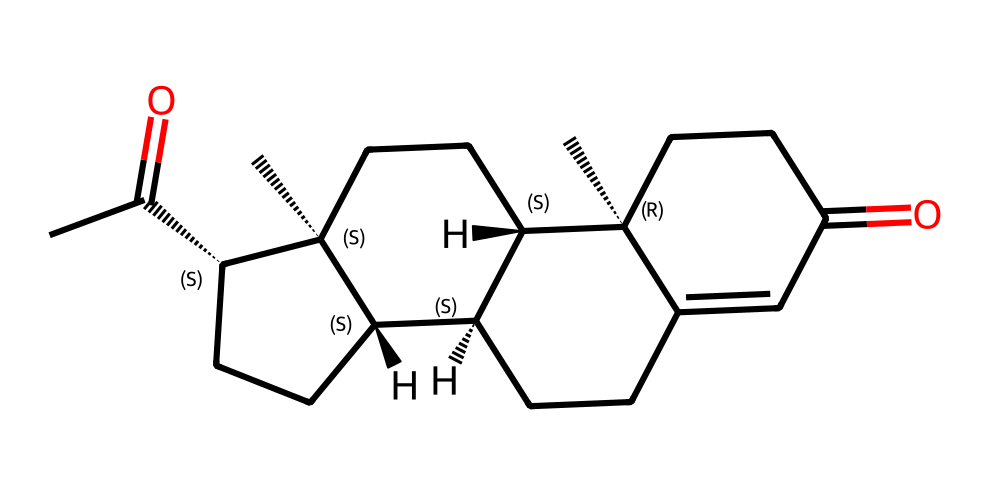What is the molecular formula of this chemical? The SMILES representation can be converted to determine the molecular formula by counting the number of each type of atom present. In this case, the chemical consists of 21 carbon atoms, 30 hydrogen atoms, and 2 oxygen atoms, leading to the formula C21H30O2.
Answer: C21H30O2 How many rings are present in the structure? By analyzing the structure represented in the SMILES, we can identify that there are four rings in the steroid-type molecule represented. This is common for lipids like progesterone.
Answer: 4 What kind of functional groups are present? The SMILES notation indicates the presence of ketones (C=O) and hydroxyl groups (if present); here, we see that the molecule contains two ketone functional groups indicated by the =O notation. There are no hydroxyl groups in the provided structure.
Answer: ketone What is the role of this hormone in pregnancy? Progesterone plays a crucial role in preparing the uterus for implantation and maintaining pregnancy. It helps in regulating various functions in the female reproductive system due to its hormone properties.
Answer: maintains pregnancy What is the stereochemistry of this molecule? The SMILES representation includes stereochemical indicators (@) that show that there are specific chiral centers within the structure. Analyzing the molecule reveals that it has multiple stereocenters, which contribute to its biologically active form.
Answer: chiral How many hydrogen atoms are attached to each carbon in the structure? To find the number of hydrogen atoms bonded to each carbon, one should look at the structure for each carbon atom and count the hydrogen atoms directly connected to it. Generally, saturated carbons can bond with up to four atoms including functional groups. In this case, overall, the structure contains 30 hydrogen.
Answer: varies Is this molecule hydrophilic or hydrophobic? Given the structure of the molecule includes predominantly hydrocarbon chains and only two polar functional groups, it suggests that the compound is primarily hydrophobic. This is a common characteristic of lipid molecules like progesterone.
Answer: hydrophobic 